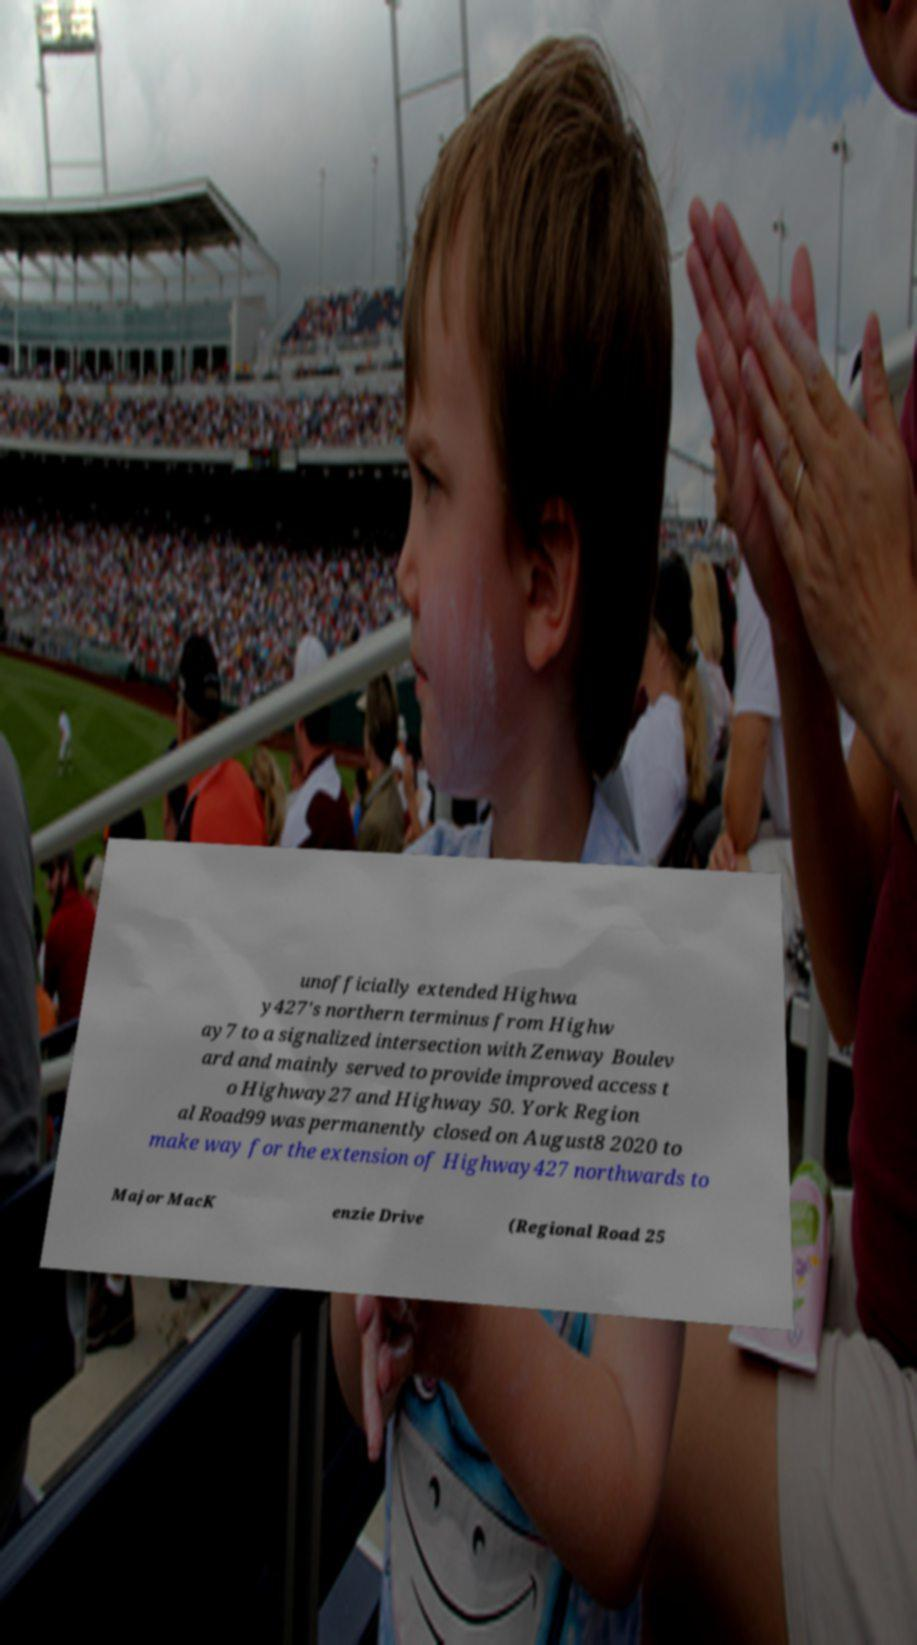Can you read and provide the text displayed in the image?This photo seems to have some interesting text. Can you extract and type it out for me? unofficially extended Highwa y427's northern terminus from Highw ay7 to a signalized intersection with Zenway Boulev ard and mainly served to provide improved access t o Highway27 and Highway 50. York Region al Road99 was permanently closed on August8 2020 to make way for the extension of Highway427 northwards to Major MacK enzie Drive (Regional Road 25 